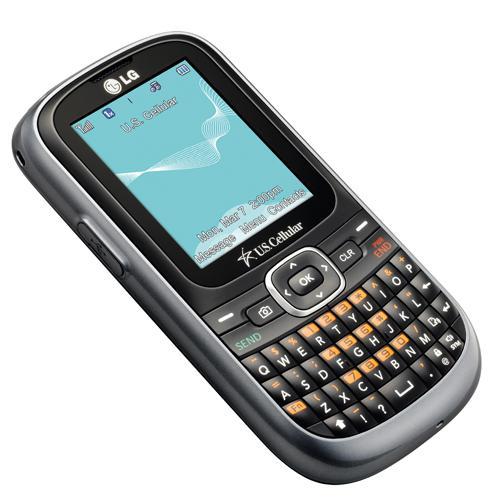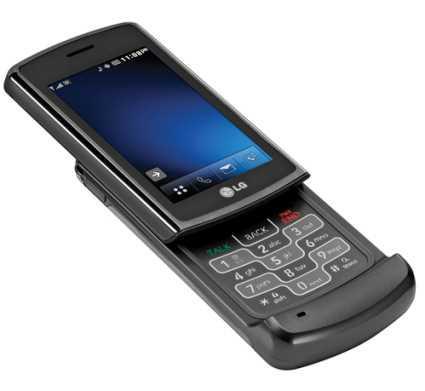The first image is the image on the left, the second image is the image on the right. Considering the images on both sides, is "One of the phones has keys that slide out from under the screen." valid? Answer yes or no. Yes. 